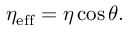<formula> <loc_0><loc_0><loc_500><loc_500>\eta _ { e f f } = \eta \cos \theta .</formula> 